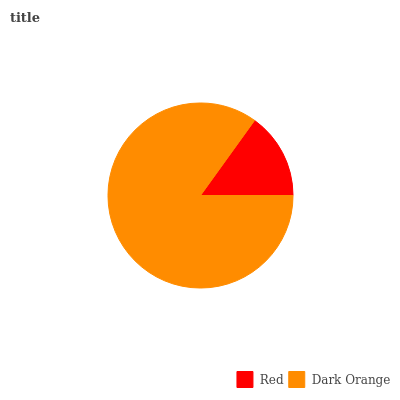Is Red the minimum?
Answer yes or no. Yes. Is Dark Orange the maximum?
Answer yes or no. Yes. Is Dark Orange the minimum?
Answer yes or no. No. Is Dark Orange greater than Red?
Answer yes or no. Yes. Is Red less than Dark Orange?
Answer yes or no. Yes. Is Red greater than Dark Orange?
Answer yes or no. No. Is Dark Orange less than Red?
Answer yes or no. No. Is Dark Orange the high median?
Answer yes or no. Yes. Is Red the low median?
Answer yes or no. Yes. Is Red the high median?
Answer yes or no. No. Is Dark Orange the low median?
Answer yes or no. No. 